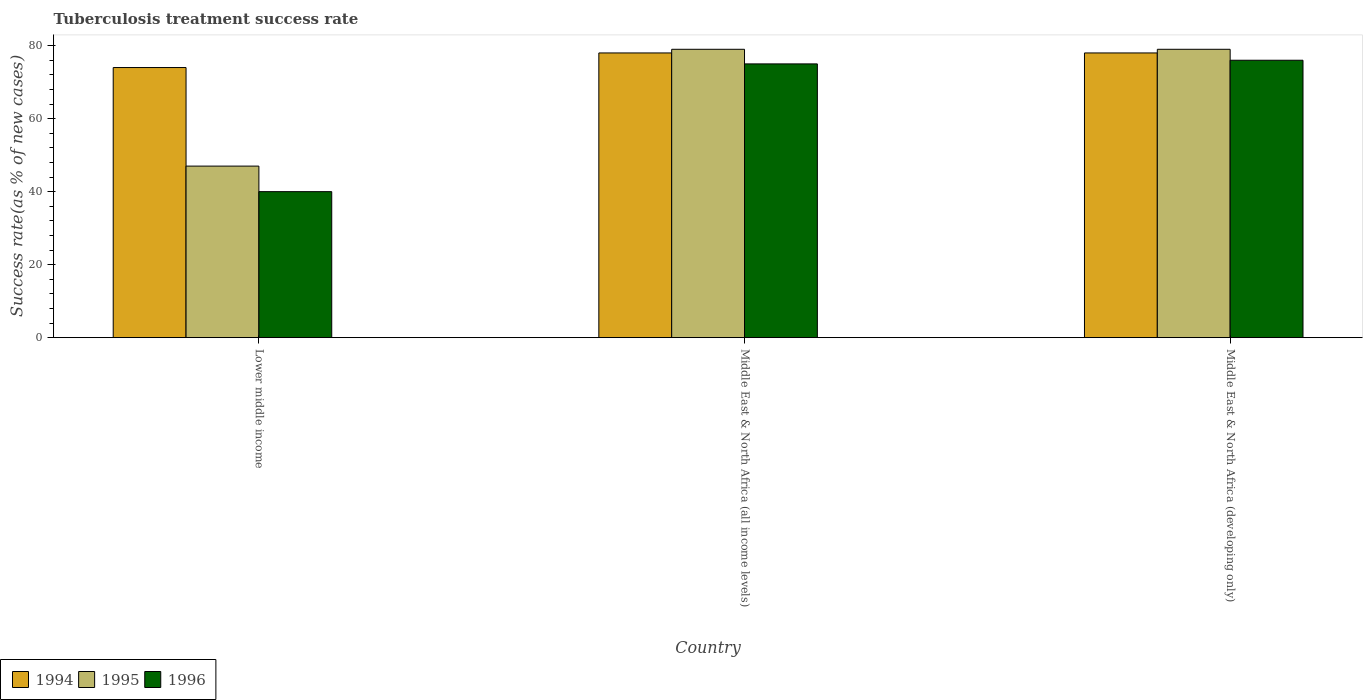How many groups of bars are there?
Make the answer very short. 3. Are the number of bars per tick equal to the number of legend labels?
Ensure brevity in your answer.  Yes. How many bars are there on the 1st tick from the right?
Provide a short and direct response. 3. What is the label of the 3rd group of bars from the left?
Ensure brevity in your answer.  Middle East & North Africa (developing only). In how many cases, is the number of bars for a given country not equal to the number of legend labels?
Provide a succinct answer. 0. What is the tuberculosis treatment success rate in 1994 in Middle East & North Africa (all income levels)?
Provide a succinct answer. 78. Across all countries, what is the maximum tuberculosis treatment success rate in 1994?
Your answer should be compact. 78. In which country was the tuberculosis treatment success rate in 1994 maximum?
Offer a very short reply. Middle East & North Africa (all income levels). In which country was the tuberculosis treatment success rate in 1995 minimum?
Your answer should be very brief. Lower middle income. What is the total tuberculosis treatment success rate in 1996 in the graph?
Your answer should be compact. 191. What is the difference between the tuberculosis treatment success rate in 1994 in Lower middle income and that in Middle East & North Africa (developing only)?
Make the answer very short. -4. What is the average tuberculosis treatment success rate in 1994 per country?
Give a very brief answer. 76.67. In how many countries, is the tuberculosis treatment success rate in 1994 greater than 68 %?
Give a very brief answer. 3. What is the ratio of the tuberculosis treatment success rate in 1994 in Lower middle income to that in Middle East & North Africa (developing only)?
Provide a succinct answer. 0.95. Is the tuberculosis treatment success rate in 1994 in Lower middle income less than that in Middle East & North Africa (all income levels)?
Your answer should be compact. Yes. Is the difference between the tuberculosis treatment success rate in 1994 in Lower middle income and Middle East & North Africa (all income levels) greater than the difference between the tuberculosis treatment success rate in 1996 in Lower middle income and Middle East & North Africa (all income levels)?
Your answer should be compact. Yes. What is the difference between the highest and the second highest tuberculosis treatment success rate in 1994?
Offer a terse response. -4. In how many countries, is the tuberculosis treatment success rate in 1994 greater than the average tuberculosis treatment success rate in 1994 taken over all countries?
Your answer should be very brief. 2. What does the 2nd bar from the right in Middle East & North Africa (all income levels) represents?
Your response must be concise. 1995. Is it the case that in every country, the sum of the tuberculosis treatment success rate in 1996 and tuberculosis treatment success rate in 1995 is greater than the tuberculosis treatment success rate in 1994?
Provide a short and direct response. Yes. How many bars are there?
Provide a succinct answer. 9. What is the difference between two consecutive major ticks on the Y-axis?
Provide a succinct answer. 20. Does the graph contain any zero values?
Provide a succinct answer. No. How are the legend labels stacked?
Make the answer very short. Horizontal. What is the title of the graph?
Provide a succinct answer. Tuberculosis treatment success rate. What is the label or title of the X-axis?
Give a very brief answer. Country. What is the label or title of the Y-axis?
Provide a succinct answer. Success rate(as % of new cases). What is the Success rate(as % of new cases) of 1996 in Lower middle income?
Provide a short and direct response. 40. What is the Success rate(as % of new cases) of 1994 in Middle East & North Africa (all income levels)?
Provide a short and direct response. 78. What is the Success rate(as % of new cases) in 1995 in Middle East & North Africa (all income levels)?
Make the answer very short. 79. What is the Success rate(as % of new cases) of 1996 in Middle East & North Africa (all income levels)?
Your response must be concise. 75. What is the Success rate(as % of new cases) in 1995 in Middle East & North Africa (developing only)?
Your answer should be very brief. 79. What is the Success rate(as % of new cases) of 1996 in Middle East & North Africa (developing only)?
Give a very brief answer. 76. Across all countries, what is the maximum Success rate(as % of new cases) in 1994?
Offer a very short reply. 78. Across all countries, what is the maximum Success rate(as % of new cases) of 1995?
Provide a succinct answer. 79. What is the total Success rate(as % of new cases) of 1994 in the graph?
Provide a succinct answer. 230. What is the total Success rate(as % of new cases) of 1995 in the graph?
Your answer should be very brief. 205. What is the total Success rate(as % of new cases) in 1996 in the graph?
Your answer should be compact. 191. What is the difference between the Success rate(as % of new cases) of 1994 in Lower middle income and that in Middle East & North Africa (all income levels)?
Make the answer very short. -4. What is the difference between the Success rate(as % of new cases) in 1995 in Lower middle income and that in Middle East & North Africa (all income levels)?
Give a very brief answer. -32. What is the difference between the Success rate(as % of new cases) in 1996 in Lower middle income and that in Middle East & North Africa (all income levels)?
Your response must be concise. -35. What is the difference between the Success rate(as % of new cases) in 1995 in Lower middle income and that in Middle East & North Africa (developing only)?
Keep it short and to the point. -32. What is the difference between the Success rate(as % of new cases) of 1996 in Lower middle income and that in Middle East & North Africa (developing only)?
Provide a short and direct response. -36. What is the difference between the Success rate(as % of new cases) in 1995 in Lower middle income and the Success rate(as % of new cases) in 1996 in Middle East & North Africa (all income levels)?
Ensure brevity in your answer.  -28. What is the average Success rate(as % of new cases) in 1994 per country?
Offer a very short reply. 76.67. What is the average Success rate(as % of new cases) of 1995 per country?
Offer a terse response. 68.33. What is the average Success rate(as % of new cases) of 1996 per country?
Offer a terse response. 63.67. What is the difference between the Success rate(as % of new cases) in 1994 and Success rate(as % of new cases) in 1996 in Lower middle income?
Keep it short and to the point. 34. What is the difference between the Success rate(as % of new cases) in 1994 and Success rate(as % of new cases) in 1996 in Middle East & North Africa (all income levels)?
Your answer should be very brief. 3. What is the difference between the Success rate(as % of new cases) in 1995 and Success rate(as % of new cases) in 1996 in Middle East & North Africa (all income levels)?
Provide a succinct answer. 4. What is the difference between the Success rate(as % of new cases) in 1994 and Success rate(as % of new cases) in 1996 in Middle East & North Africa (developing only)?
Make the answer very short. 2. What is the difference between the Success rate(as % of new cases) in 1995 and Success rate(as % of new cases) in 1996 in Middle East & North Africa (developing only)?
Ensure brevity in your answer.  3. What is the ratio of the Success rate(as % of new cases) of 1994 in Lower middle income to that in Middle East & North Africa (all income levels)?
Offer a terse response. 0.95. What is the ratio of the Success rate(as % of new cases) in 1995 in Lower middle income to that in Middle East & North Africa (all income levels)?
Your answer should be very brief. 0.59. What is the ratio of the Success rate(as % of new cases) in 1996 in Lower middle income to that in Middle East & North Africa (all income levels)?
Your answer should be very brief. 0.53. What is the ratio of the Success rate(as % of new cases) of 1994 in Lower middle income to that in Middle East & North Africa (developing only)?
Give a very brief answer. 0.95. What is the ratio of the Success rate(as % of new cases) in 1995 in Lower middle income to that in Middle East & North Africa (developing only)?
Your response must be concise. 0.59. What is the ratio of the Success rate(as % of new cases) of 1996 in Lower middle income to that in Middle East & North Africa (developing only)?
Your answer should be compact. 0.53. What is the ratio of the Success rate(as % of new cases) in 1994 in Middle East & North Africa (all income levels) to that in Middle East & North Africa (developing only)?
Ensure brevity in your answer.  1. What is the difference between the highest and the second highest Success rate(as % of new cases) of 1995?
Give a very brief answer. 0. What is the difference between the highest and the second highest Success rate(as % of new cases) in 1996?
Offer a terse response. 1. 